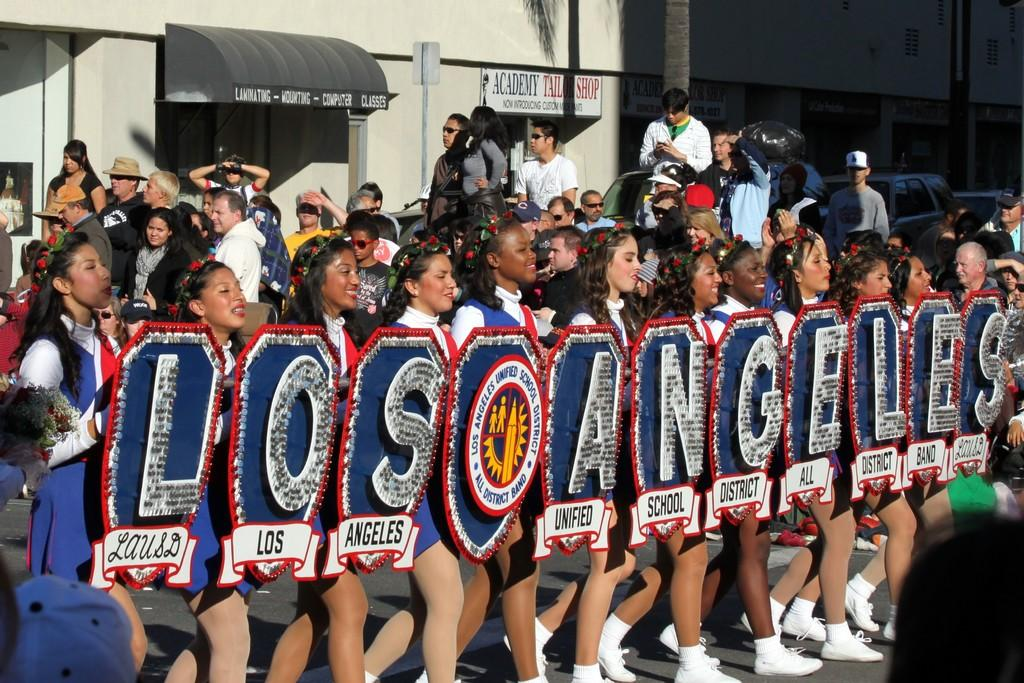Provide a one-sentence caption for the provided image. Women in a parade hold up signs that spell out Los Angeles. 